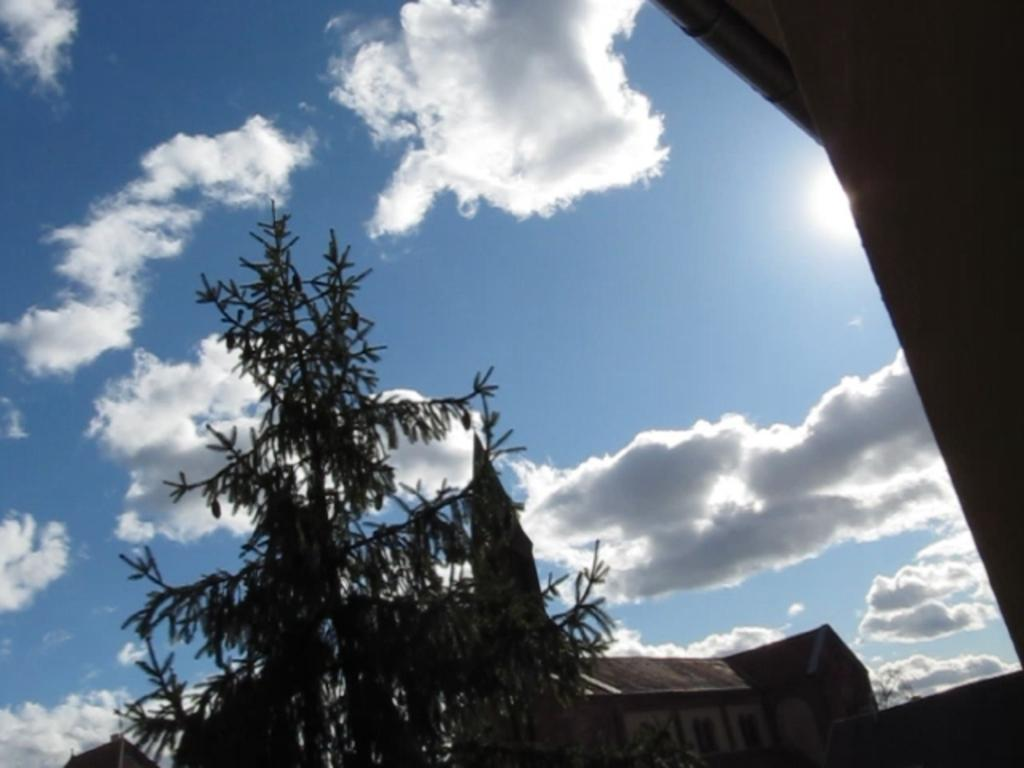What is the main structure in the center of the image? There is a building in the center of the image. What type of natural elements can be seen in the image? Trees are present in the image. What architectural feature is on the right side of the image? There is a wall on the right side of the image. What is visible in the sky at the top of the image? Clouds are visible in the sky at the top of the image. What type of copy is the governor holding in the image? There is no governor or copy present in the image. How many drops of water can be seen falling from the clouds in the image? There is no indication of rain or water droplets in the image; only clouds are visible in the sky. 